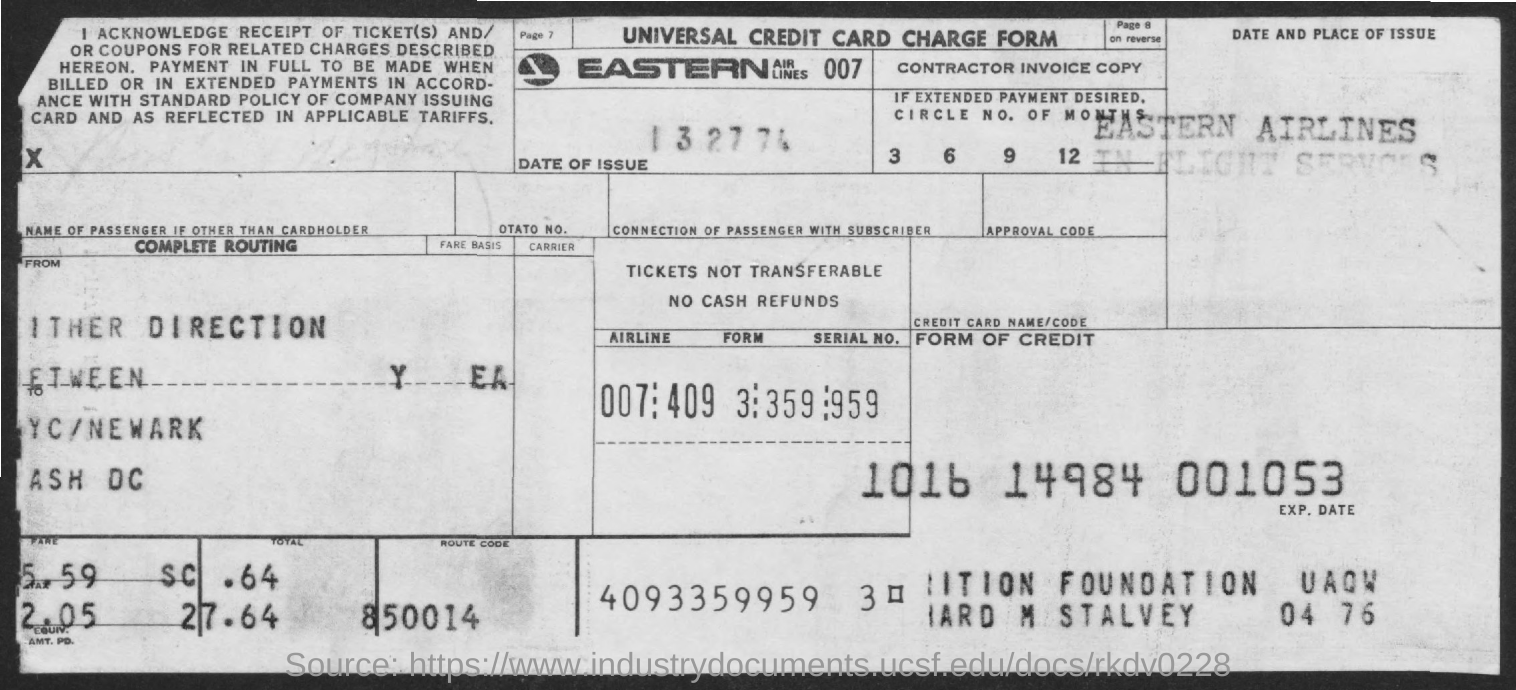Highlight a few significant elements in this photo. The form known as universal credit card charge is a declaration. What is the route code?" is a question. "850014" is a code. The code represents a route, but it is not clear what route is being referred to. 